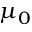<formula> <loc_0><loc_0><loc_500><loc_500>\mu _ { 0 }</formula> 